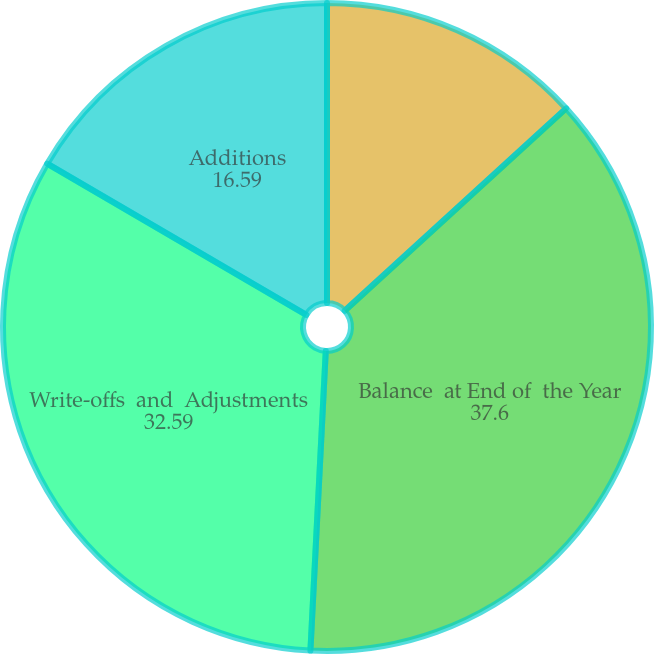<chart> <loc_0><loc_0><loc_500><loc_500><pie_chart><fcel>Balance at  Beginning  of the Year<fcel>Balance  at End of  the Year<fcel>Write-offs  and  Adjustments<fcel>Additions<nl><fcel>13.21%<fcel>37.6%<fcel>32.59%<fcel>16.59%<nl></chart> 